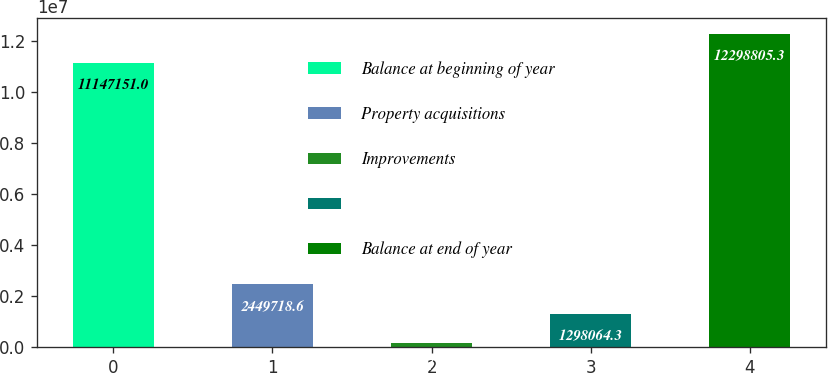Convert chart to OTSL. <chart><loc_0><loc_0><loc_500><loc_500><bar_chart><fcel>Balance at beginning of year<fcel>Property acquisitions<fcel>Improvements<fcel>Unnamed: 3<fcel>Balance at end of year<nl><fcel>1.11472e+07<fcel>2.44972e+06<fcel>146410<fcel>1.29806e+06<fcel>1.22988e+07<nl></chart> 